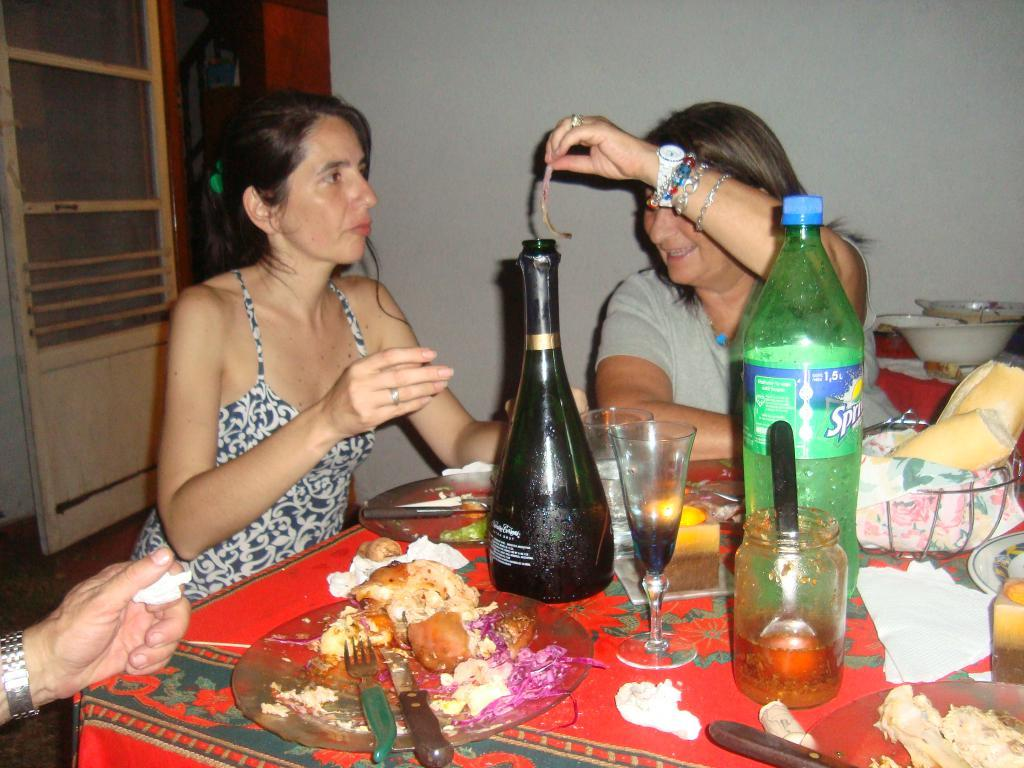<image>
Give a short and clear explanation of the subsequent image. A bottle of Sprite is on a table with other items. 